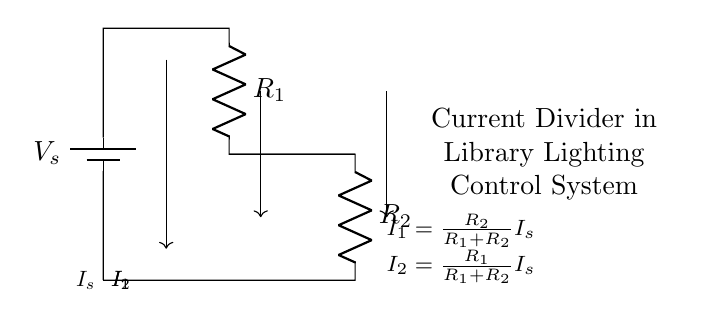What are the components in this circuit? The circuit contains a battery, two resistors (R1 and R2), and several connections.
Answer: battery, R1, R2 What does the variable V_s represent in this circuit? V_s represents the voltage supplied by the battery at the top of the circuit.
Answer: voltage supplied What is the relationship between I1 and I_s? I1 is calculated as I_s times the ratio of R2 over the total resistance (R1 + R2), reflecting how the current divides.
Answer: I1 = R2/(R1 + R2) I_s How many branches are present in this current divider circuit? There are two branches for current to flow through, corresponding to resistors R1 and R2.
Answer: two branches What determines the distribution of current in this circuit? The distribution of current is determined by the values of the resistances R1 and R2, as per the current divider rule.
Answer: values of R1 and R2 What is the current flowing through R2 (I2) if I_s is 10A and R1 = 2Ω, R2 = 3Ω? Using the formula I2 = (R1/(R1 + R2)) * I_s, we can calculate I2. Here, I2 = (2/(2 + 3)) * 10 = 4A.
Answer: 4A 